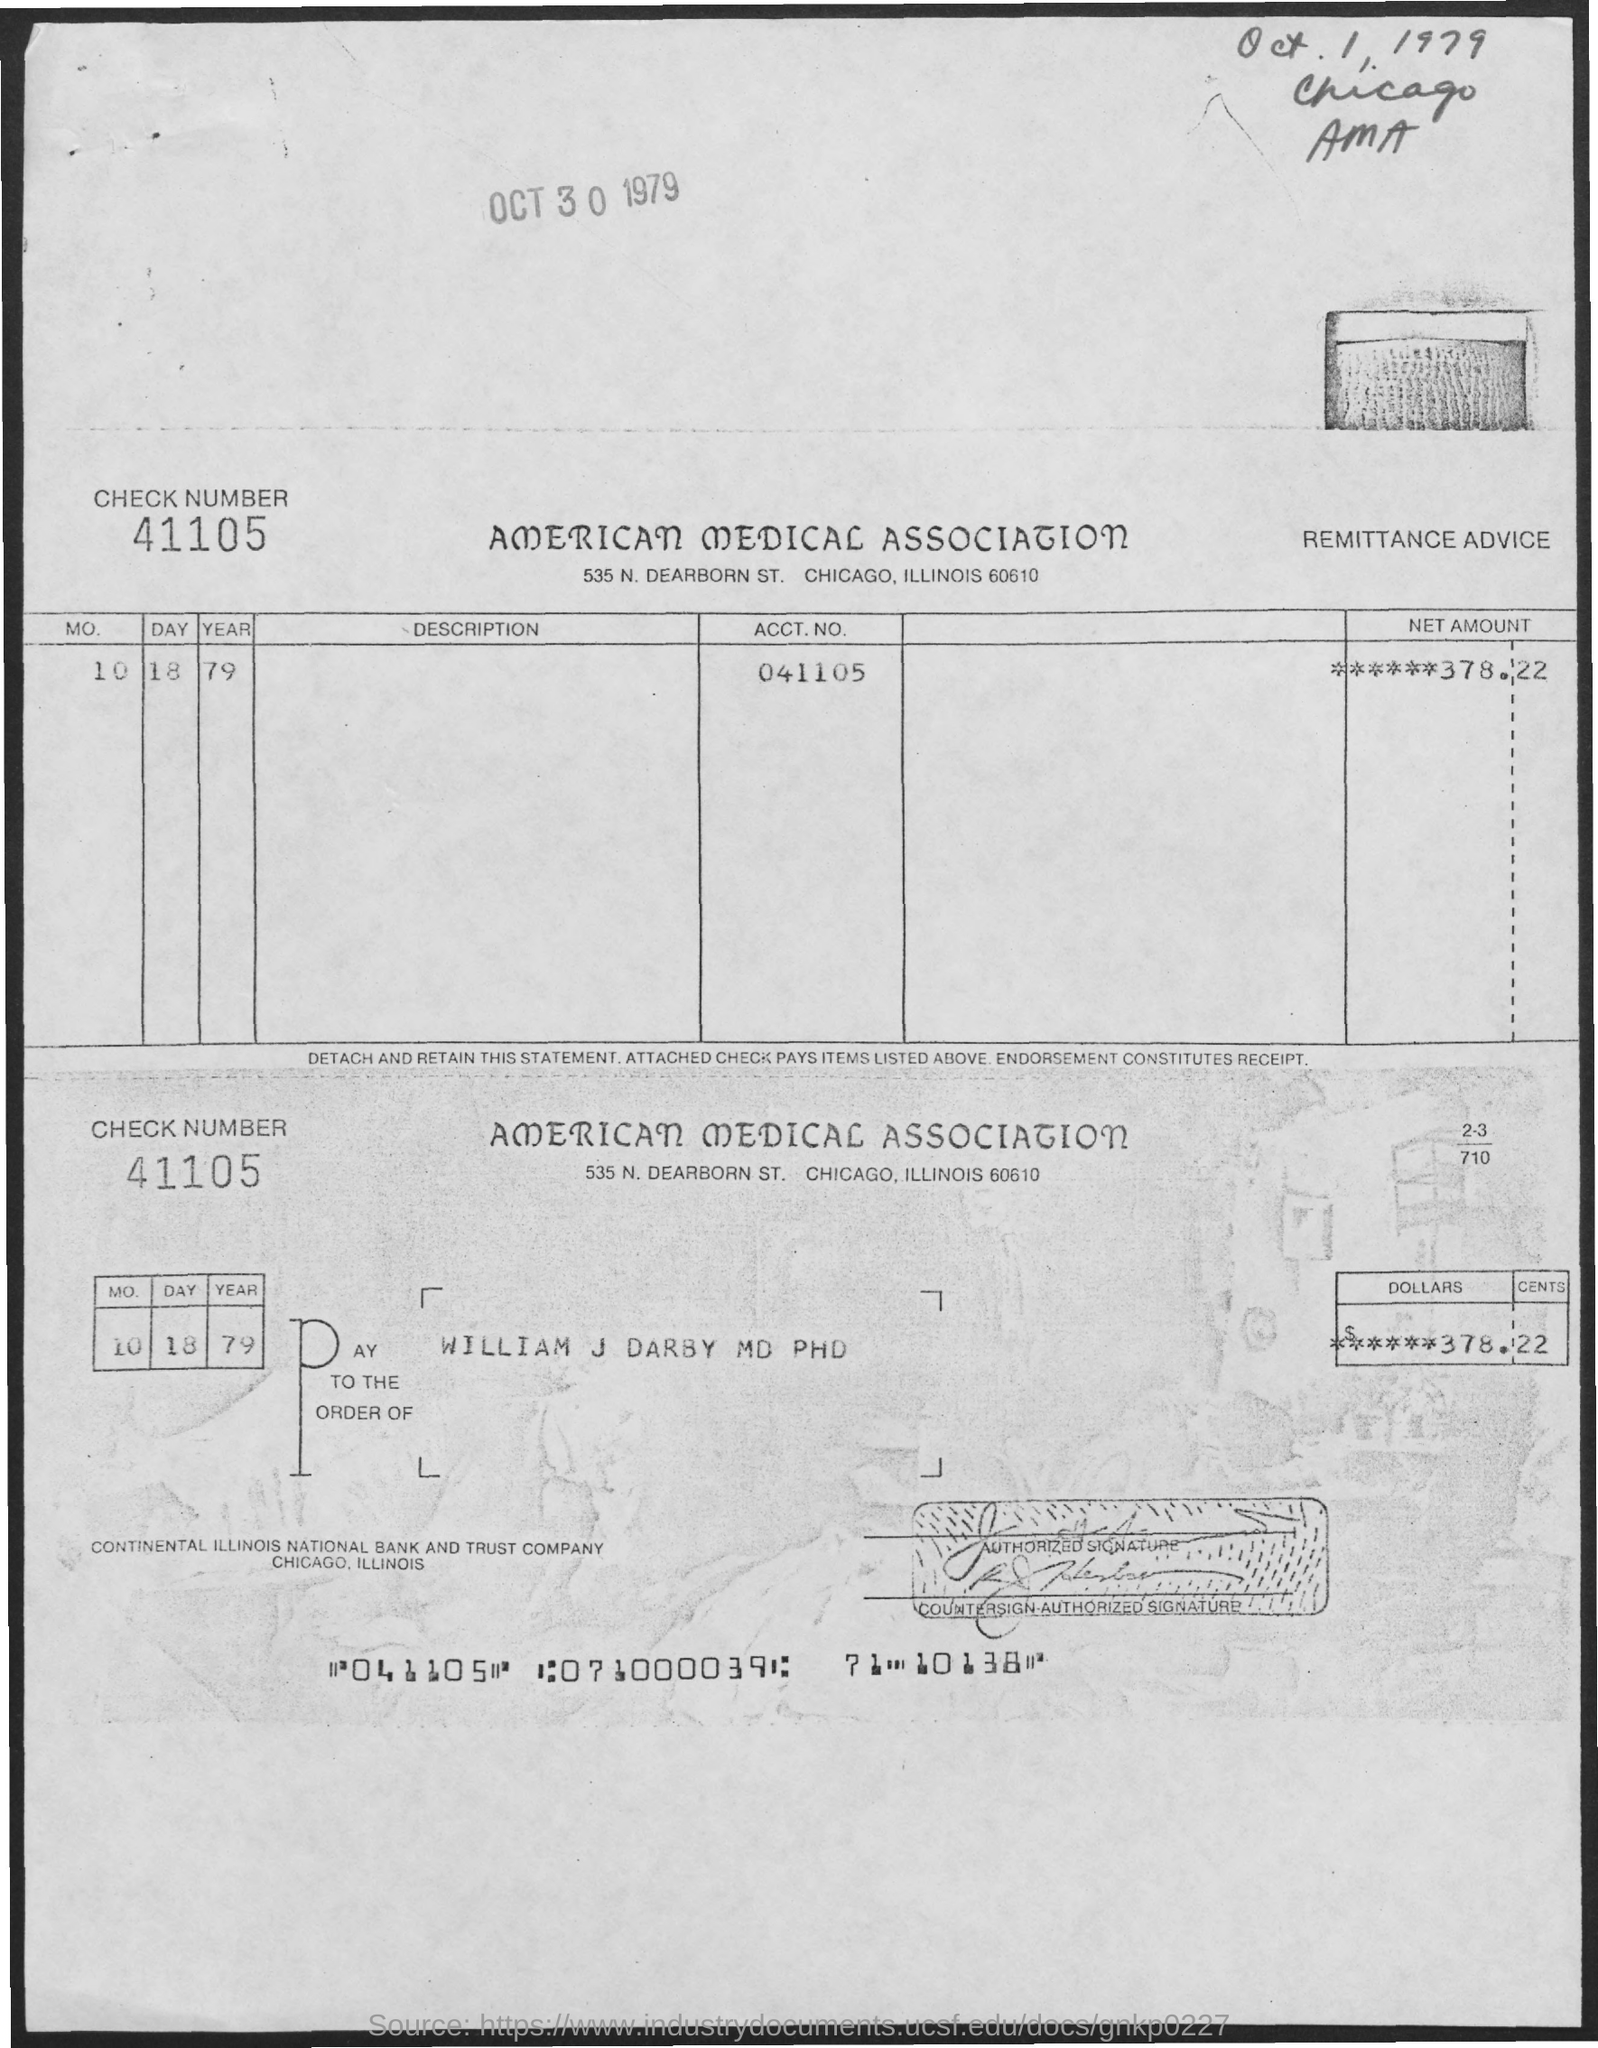What is the check number mentioned here?
Provide a succinct answer. 41105. What is the payee's name given in the check?
Ensure brevity in your answer.  William j darby md phd. What is the check amount mentioned in the check?
Ensure brevity in your answer.  ******378.22. What is the date mentioned in the check?
Give a very brief answer. 10 18 79. What is the ACCT.NO given in the receipt?
Keep it short and to the point. 041105. 